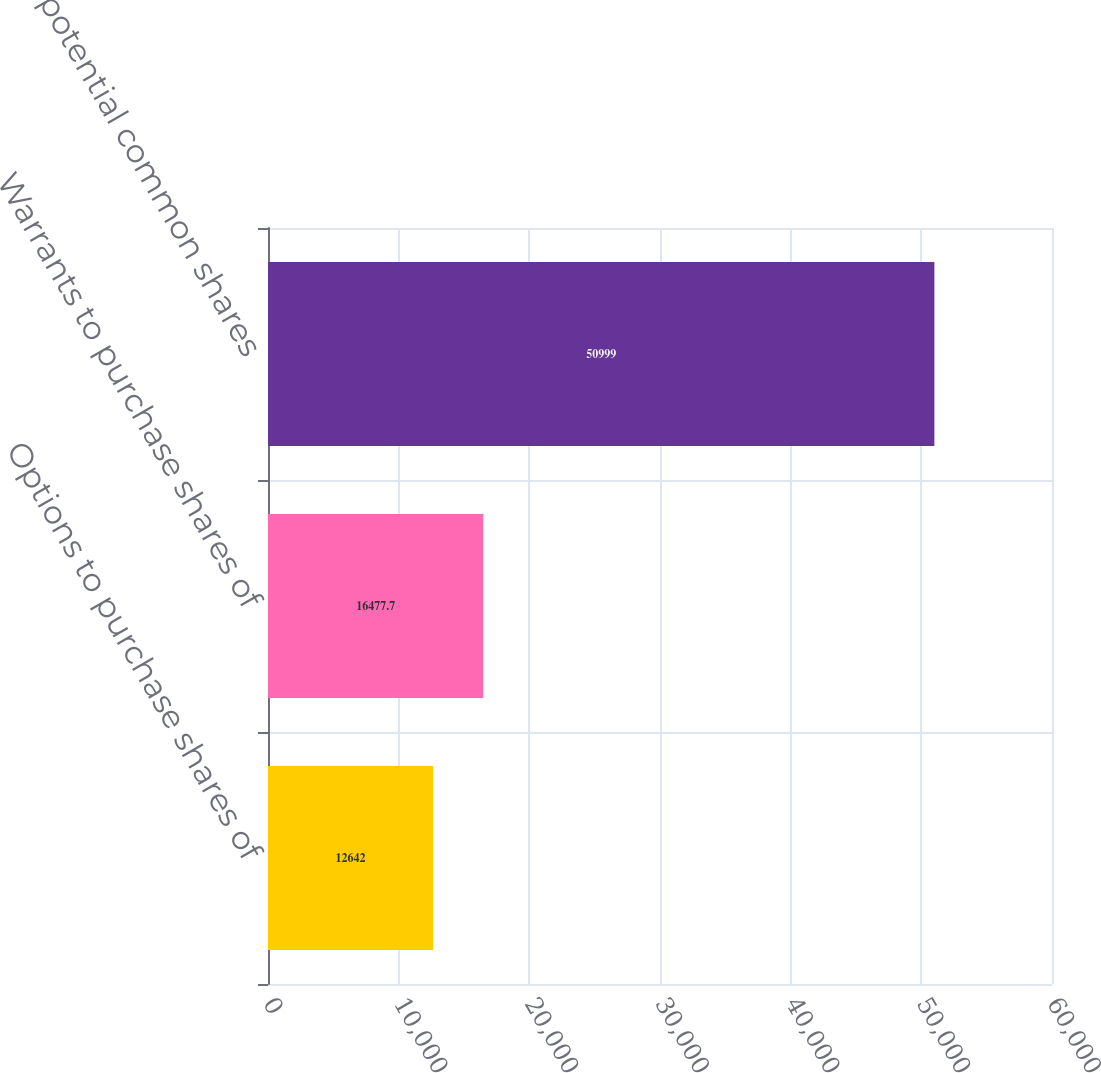Convert chart. <chart><loc_0><loc_0><loc_500><loc_500><bar_chart><fcel>Options to purchase shares of<fcel>Warrants to purchase shares of<fcel>Total potential common shares<nl><fcel>12642<fcel>16477.7<fcel>50999<nl></chart> 